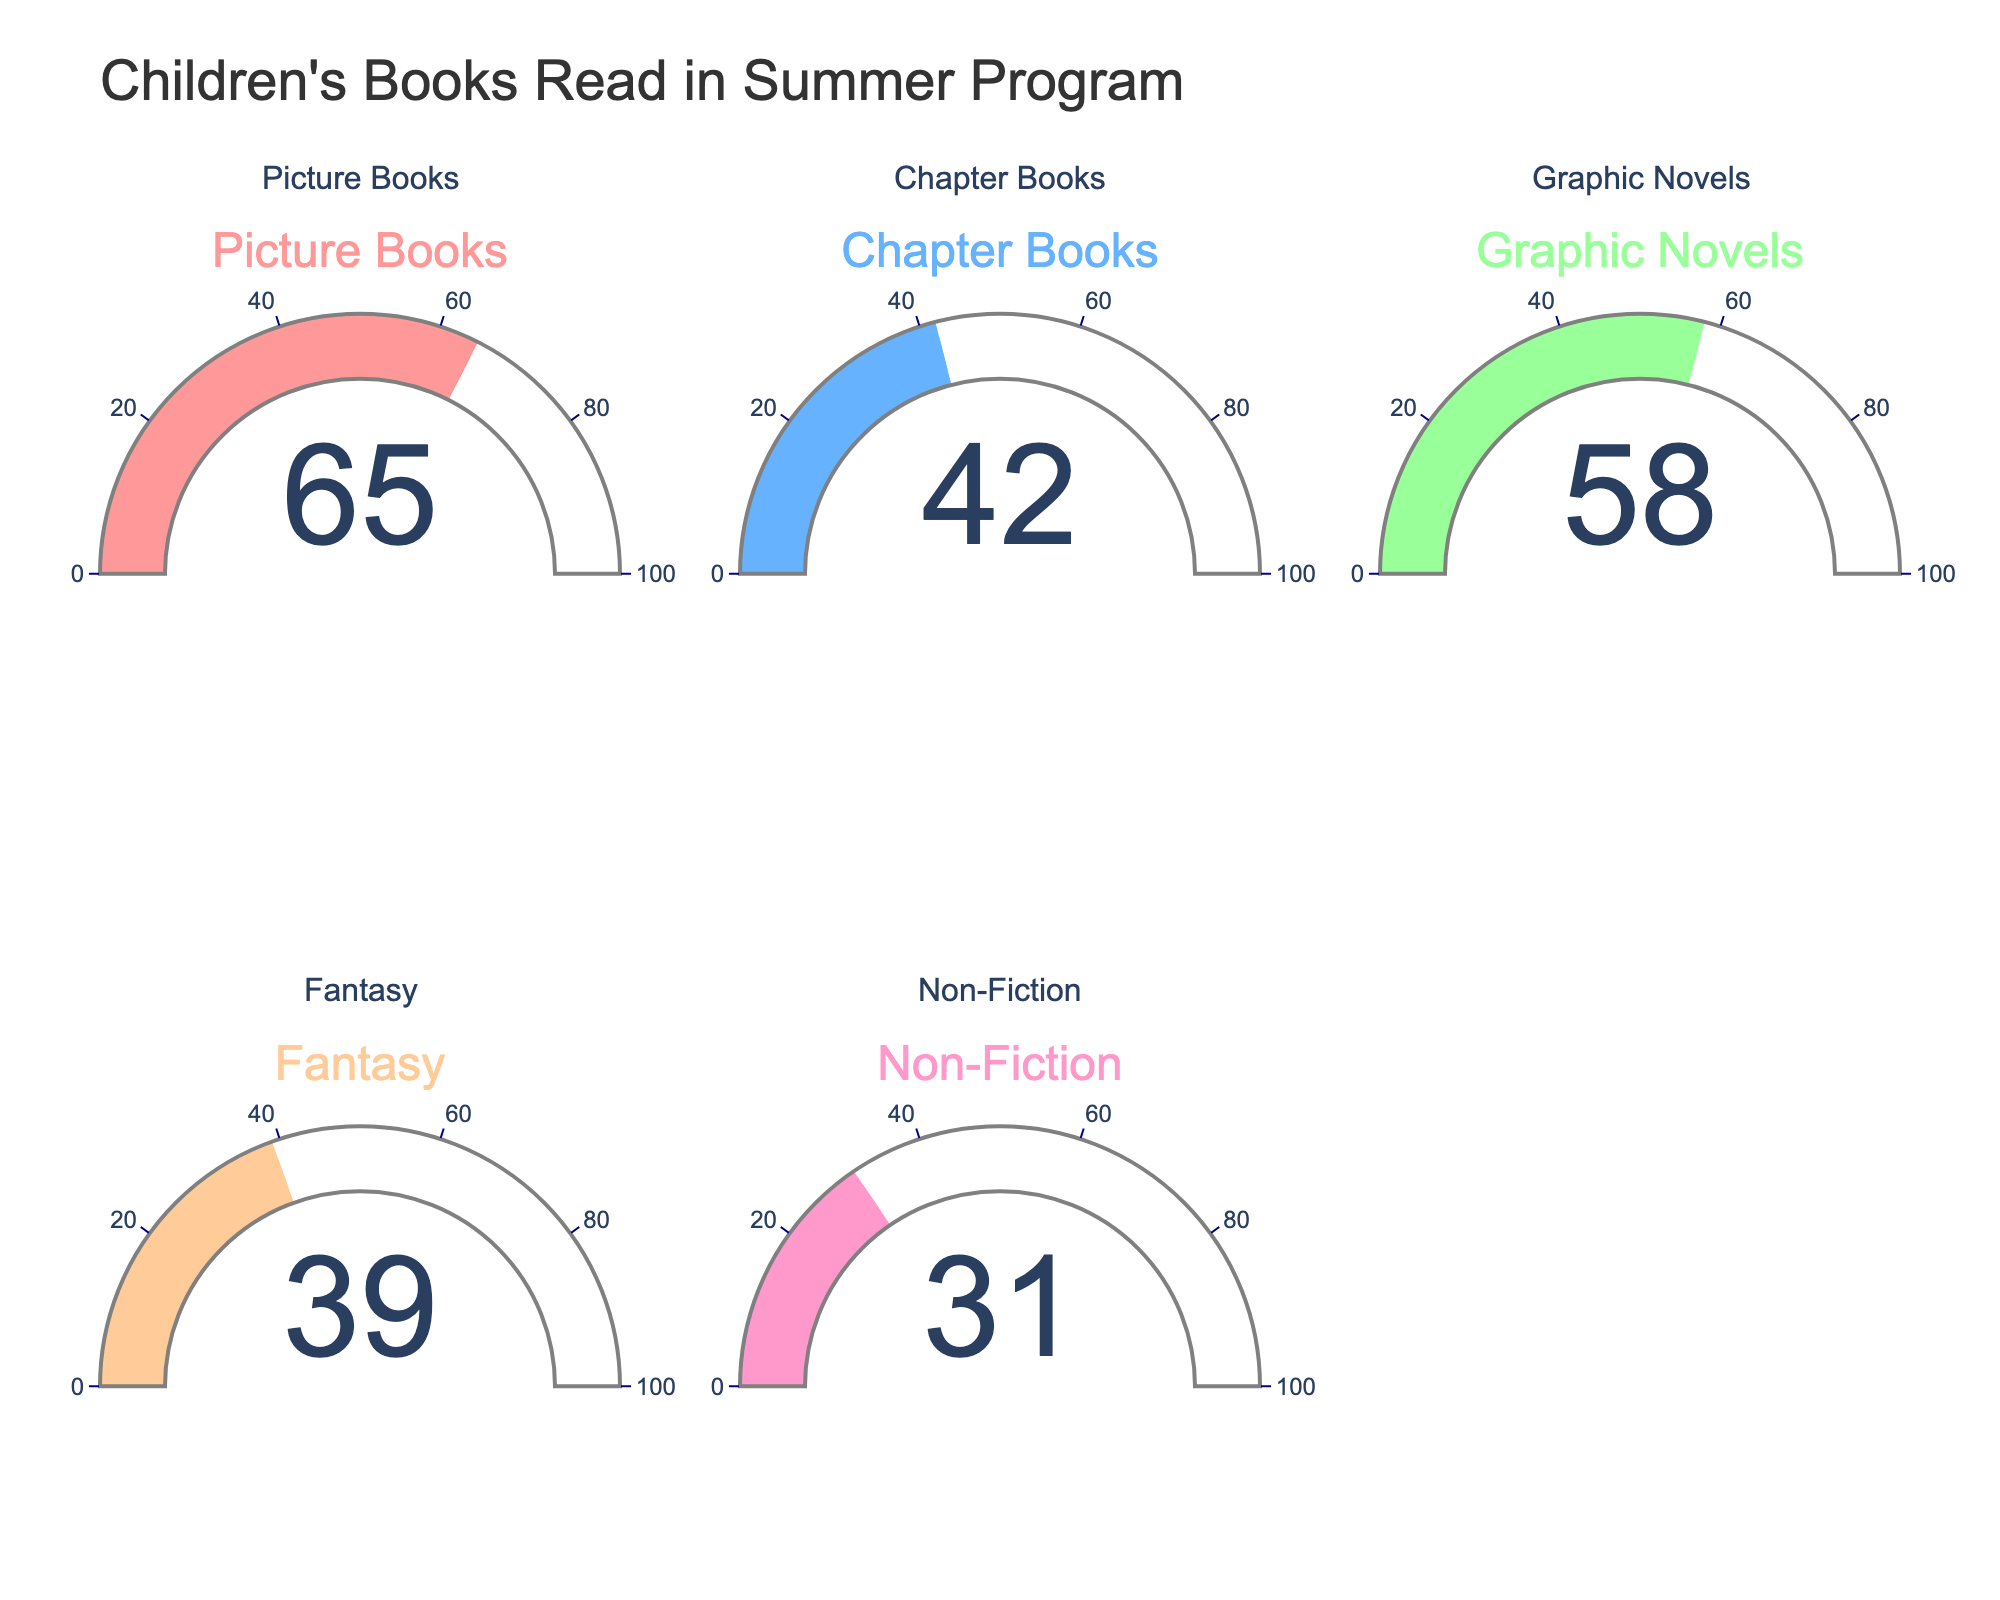What is the title of the figure? The title of the figure is displayed at the top center. It reads "Children's Books Read in Summer Program".
Answer: Children's Books Read in Summer Program What percentage of Picture Books were read? The gauge chart for Picture Books shows a number indicating the percentage of books read.
Answer: 65% Which genre has the lowest percentage of books read? By looking at all the gauge charts, we compare the percentage values. Non-Fiction has the lowest percentage.
Answer: Non-Fiction What is the average percentage of books read across all genres? To find the average, add the percentages of all genres and divide by the number of genres. (65 + 42 + 58 + 39 + 31) / 5 = 235 / 5 = 47
Answer: 47 Which genre has a higher reading percentage, Chapter Books or Graphic Novels? Compare the gauge charts for Chapter Books and Graphic Novels. Graphic Novels has a higher percentage (58% vs 42%).
Answer: Graphic Novels What is the difference in reading percentage between Picture Books and Fantasy? Subtract the percentage for Fantasy from the percentage for Picture Books. 65 - 39 = 26
Answer: 26 How many genres have a reading percentage above 50%? Identify the genres with percentages above 50% by examining each gauge chart. Picture Books and Graphic Novels are above 50%.
Answer: 2 What is the range of reading percentages across all genres? The range is the difference between the highest and lowest percentages. 65 - 31 = 34
Answer: 34 What is the median reading percentage of the genres? The median is the middle value when the percentages are listed in ascending order: 31, 39, 42, 58, 65. The median is 42.
Answer: 42 Arrange the genres in descending order of reading percentages. List the genres based on their percentages from highest to lowest: Picture Books, Graphic Novels, Chapter Books, Fantasy, Non-Fiction.
Answer: Picture Books, Graphic Novels, Chapter Books, Fantasy, Non-Fiction 